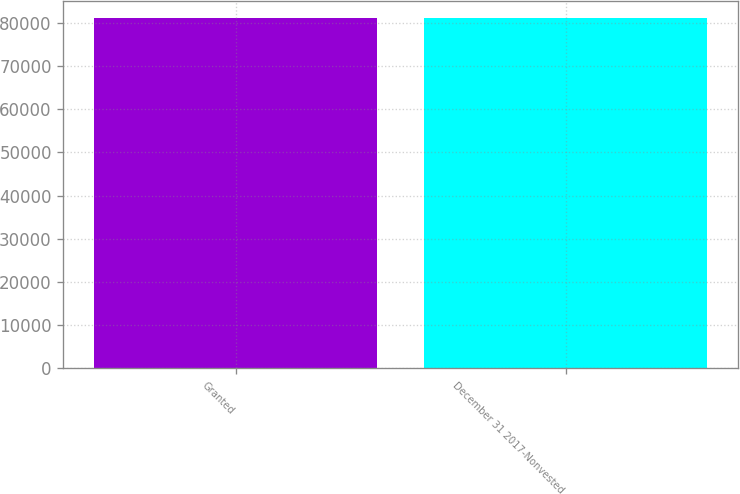<chart> <loc_0><loc_0><loc_500><loc_500><bar_chart><fcel>Granted<fcel>December 31 2017-Nonvested<nl><fcel>81068<fcel>81068.1<nl></chart> 